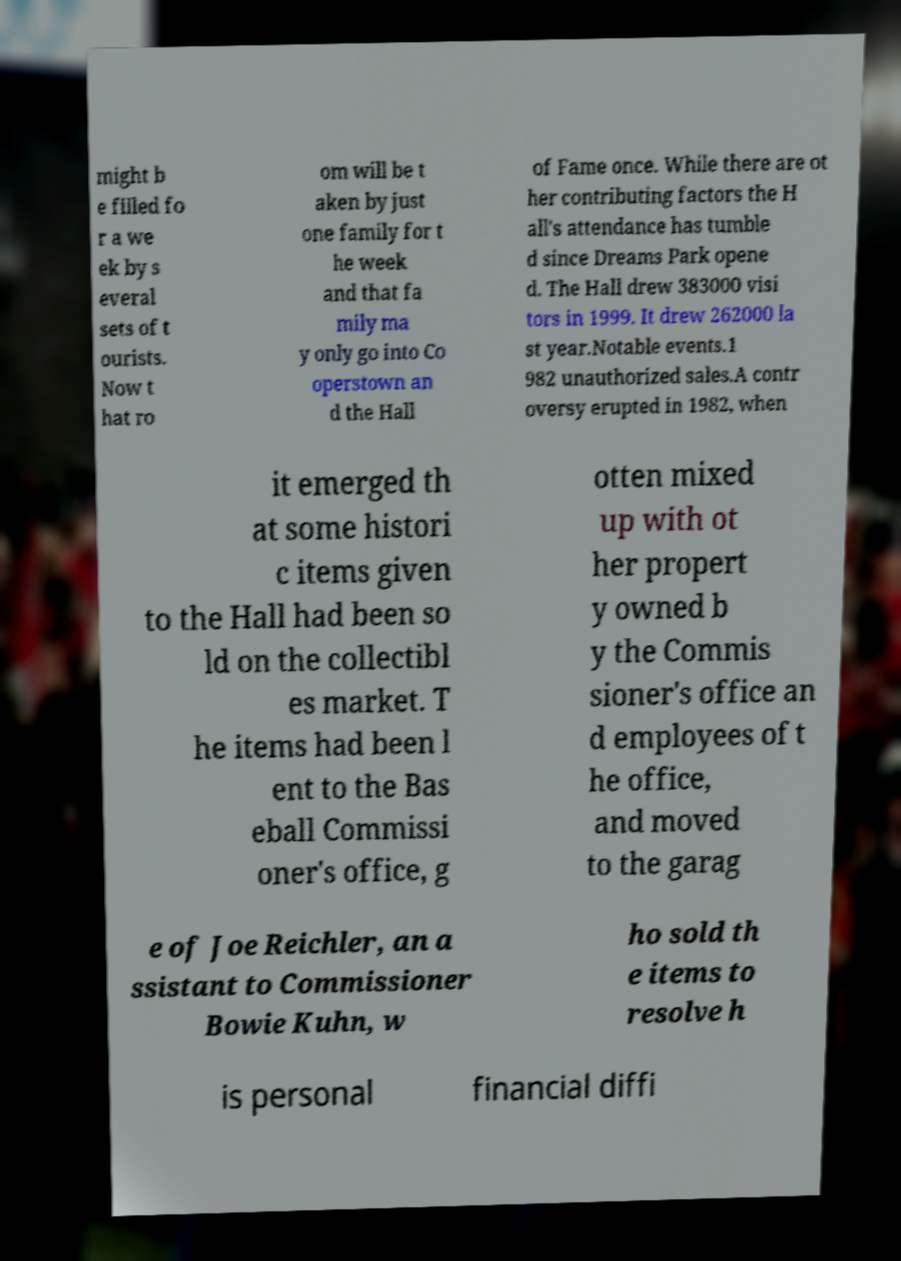What messages or text are displayed in this image? I need them in a readable, typed format. might b e filled fo r a we ek by s everal sets of t ourists. Now t hat ro om will be t aken by just one family for t he week and that fa mily ma y only go into Co operstown an d the Hall of Fame once. While there are ot her contributing factors the H all's attendance has tumble d since Dreams Park opene d. The Hall drew 383000 visi tors in 1999. It drew 262000 la st year.Notable events.1 982 unauthorized sales.A contr oversy erupted in 1982, when it emerged th at some histori c items given to the Hall had been so ld on the collectibl es market. T he items had been l ent to the Bas eball Commissi oner's office, g otten mixed up with ot her propert y owned b y the Commis sioner's office an d employees of t he office, and moved to the garag e of Joe Reichler, an a ssistant to Commissioner Bowie Kuhn, w ho sold th e items to resolve h is personal financial diffi 